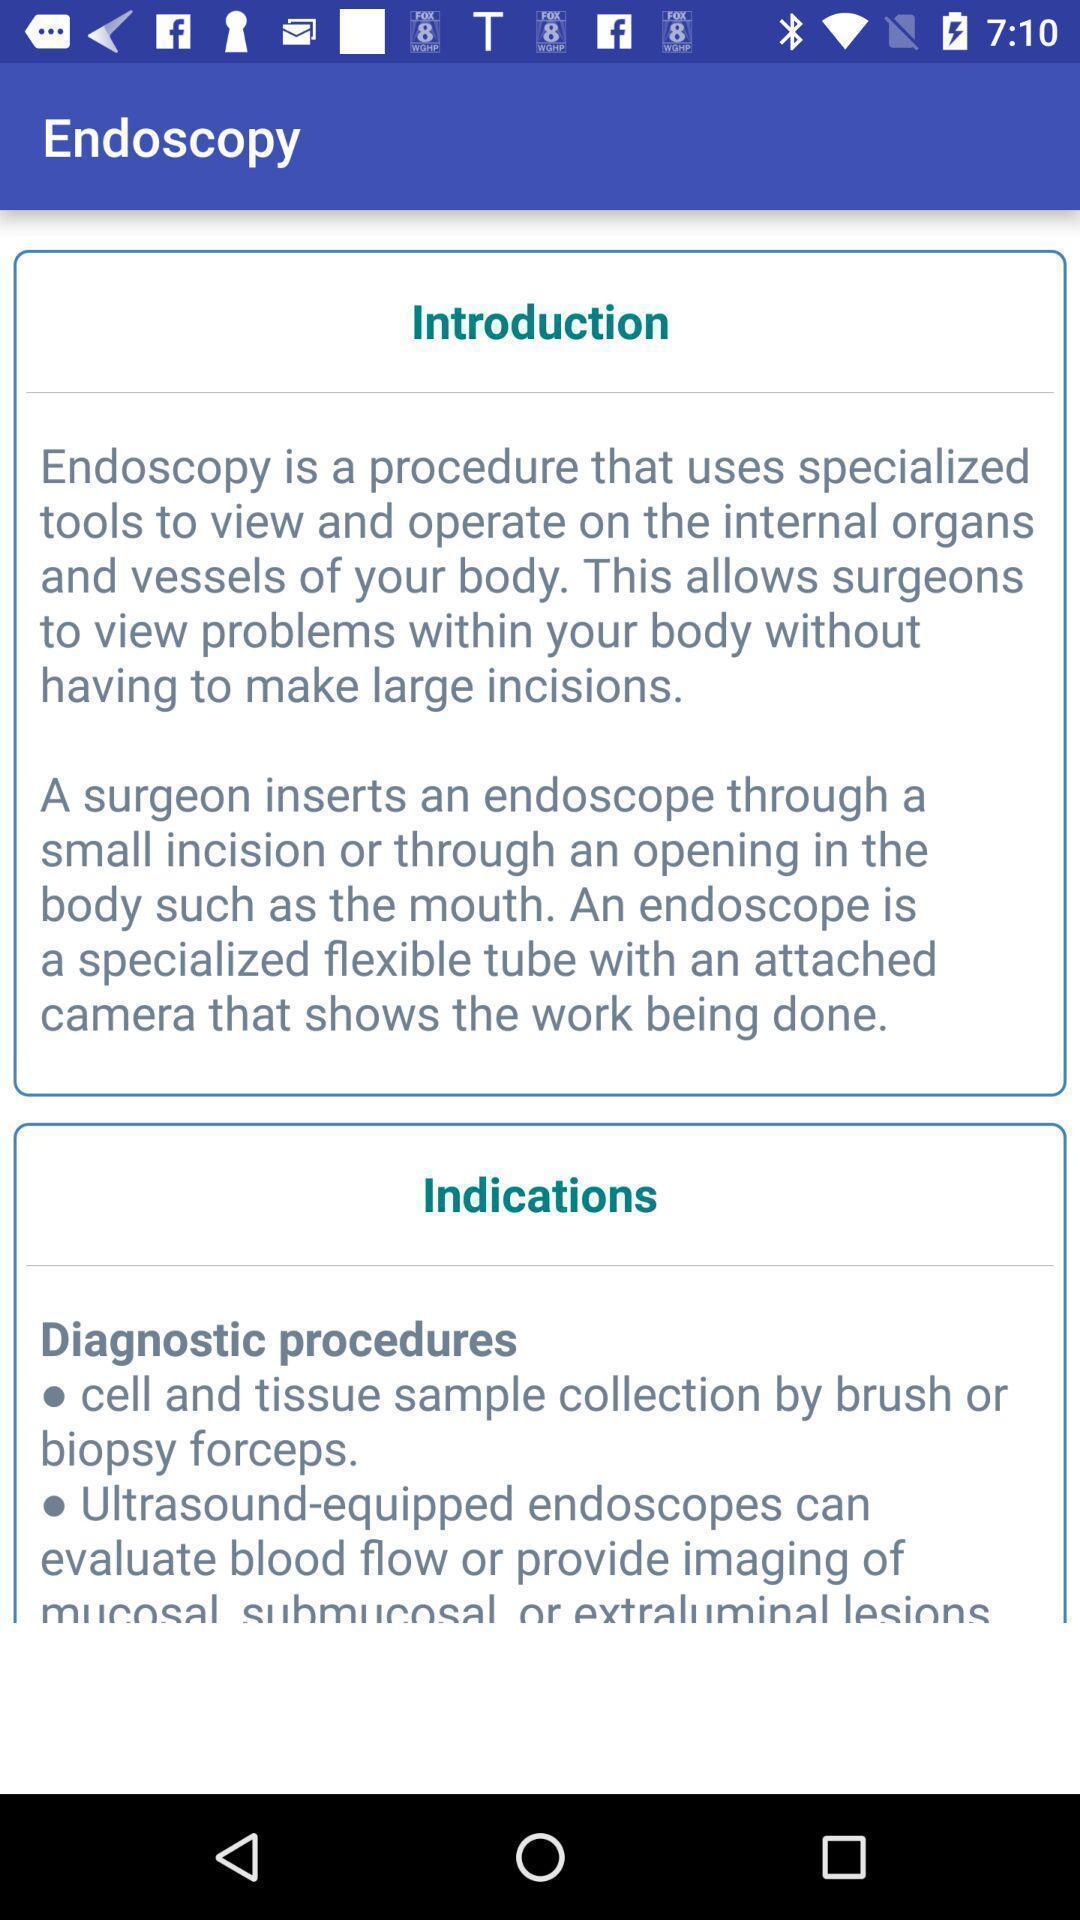Describe the visual elements of this screenshot. Screen showing introduction and indications. 